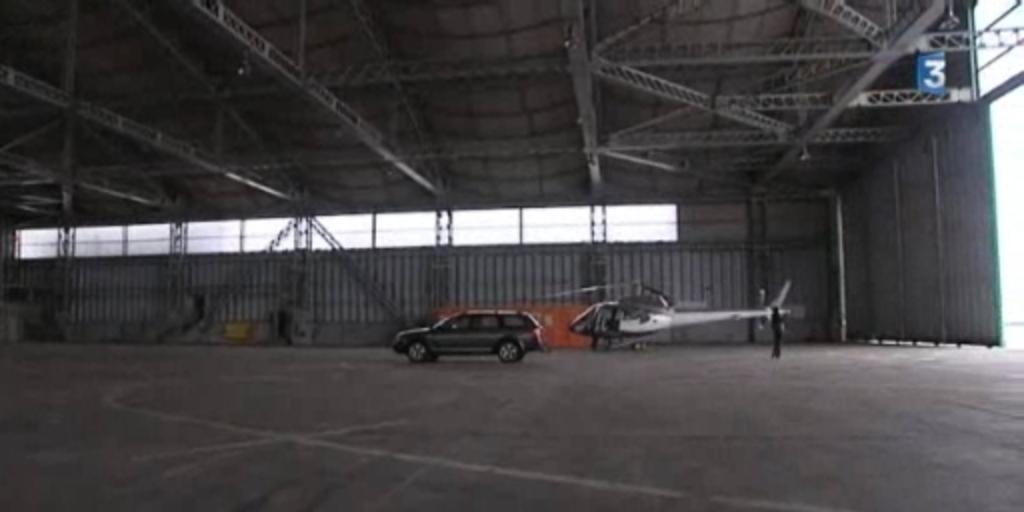<image>
Share a concise interpretation of the image provided. A blue number 3 sign hangs from the ceiling of this large building. 